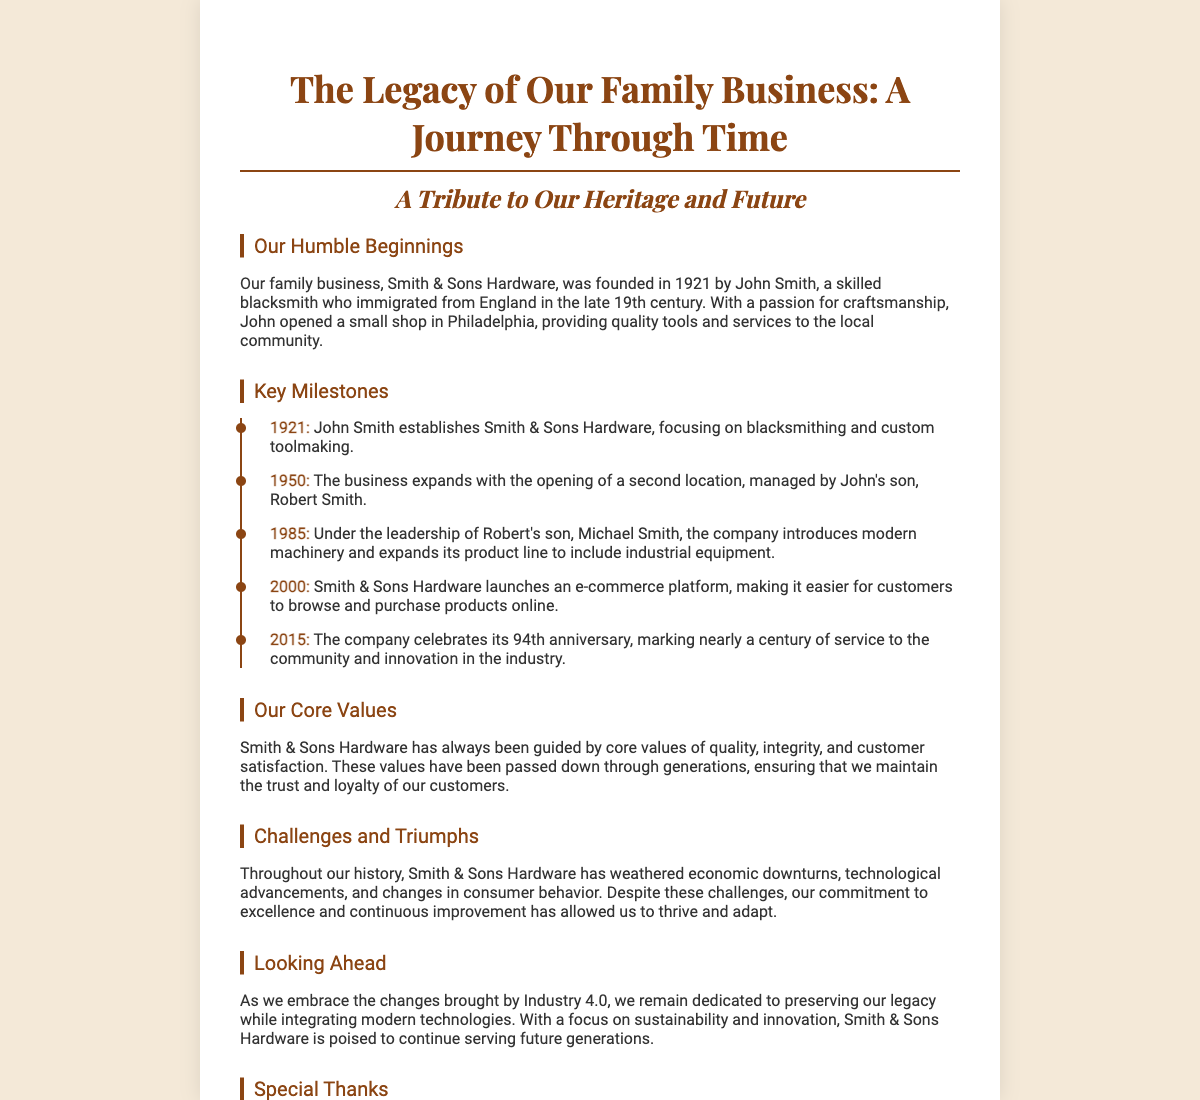What year was Smith & Sons Hardware founded? The founding year is explicitly stated in the document.
Answer: 1921 Who founded Smith & Sons Hardware? The document specifies the founder's name in the history section.
Answer: John Smith In what year did the business expand with a second location? The timeline lists the year when the second location was opened.
Answer: 1950 What was introduced under Michael Smith's leadership in 1985? The document outlines the key milestones, including this specific innovation.
Answer: Modern machinery What anniversary did the company celebrate in 2015? The anniversary mentioned in the text reflects an important milestone in the company's history.
Answer: 94th anniversary What core values guide Smith & Sons Hardware? The document highlights the core values in a dedicated section, summarizing them succinctly.
Answer: Quality, integrity, customer satisfaction What challenges has Smith & Sons Hardware faced? The challenges are summarized in a single phrase in the document.
Answer: Economic downturns, technological advancements, changes in consumer behavior What focus does Smith & Sons Hardware have for the future? The document discusses the future plans in a specific section regarding Industry 4.0.
Answer: Sustainability and innovation 